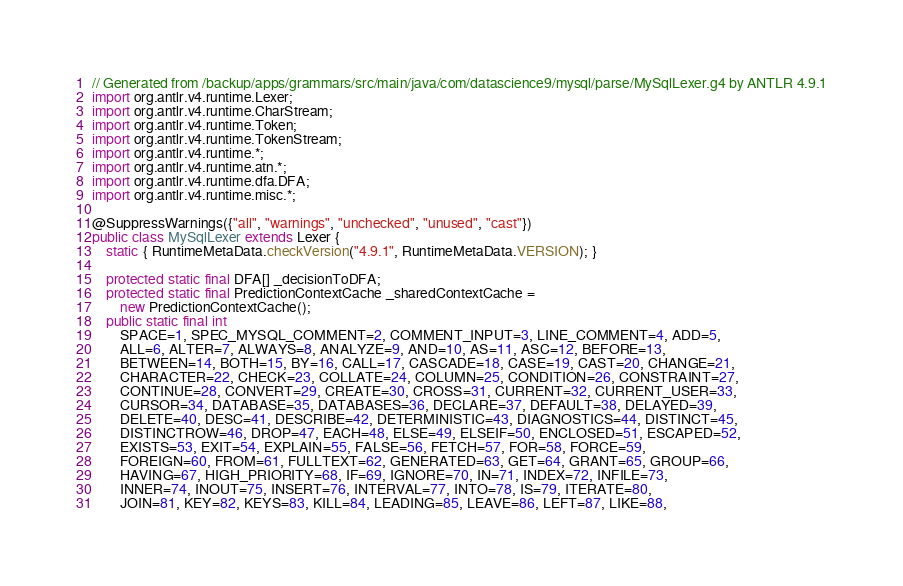Convert code to text. <code><loc_0><loc_0><loc_500><loc_500><_Java_>// Generated from /backup/apps/grammars/src/main/java/com/datascience9/mysql/parse/MySqlLexer.g4 by ANTLR 4.9.1
import org.antlr.v4.runtime.Lexer;
import org.antlr.v4.runtime.CharStream;
import org.antlr.v4.runtime.Token;
import org.antlr.v4.runtime.TokenStream;
import org.antlr.v4.runtime.*;
import org.antlr.v4.runtime.atn.*;
import org.antlr.v4.runtime.dfa.DFA;
import org.antlr.v4.runtime.misc.*;

@SuppressWarnings({"all", "warnings", "unchecked", "unused", "cast"})
public class MySqlLexer extends Lexer {
	static { RuntimeMetaData.checkVersion("4.9.1", RuntimeMetaData.VERSION); }

	protected static final DFA[] _decisionToDFA;
	protected static final PredictionContextCache _sharedContextCache =
		new PredictionContextCache();
	public static final int
		SPACE=1, SPEC_MYSQL_COMMENT=2, COMMENT_INPUT=3, LINE_COMMENT=4, ADD=5, 
		ALL=6, ALTER=7, ALWAYS=8, ANALYZE=9, AND=10, AS=11, ASC=12, BEFORE=13, 
		BETWEEN=14, BOTH=15, BY=16, CALL=17, CASCADE=18, CASE=19, CAST=20, CHANGE=21, 
		CHARACTER=22, CHECK=23, COLLATE=24, COLUMN=25, CONDITION=26, CONSTRAINT=27, 
		CONTINUE=28, CONVERT=29, CREATE=30, CROSS=31, CURRENT=32, CURRENT_USER=33, 
		CURSOR=34, DATABASE=35, DATABASES=36, DECLARE=37, DEFAULT=38, DELAYED=39, 
		DELETE=40, DESC=41, DESCRIBE=42, DETERMINISTIC=43, DIAGNOSTICS=44, DISTINCT=45, 
		DISTINCTROW=46, DROP=47, EACH=48, ELSE=49, ELSEIF=50, ENCLOSED=51, ESCAPED=52, 
		EXISTS=53, EXIT=54, EXPLAIN=55, FALSE=56, FETCH=57, FOR=58, FORCE=59, 
		FOREIGN=60, FROM=61, FULLTEXT=62, GENERATED=63, GET=64, GRANT=65, GROUP=66, 
		HAVING=67, HIGH_PRIORITY=68, IF=69, IGNORE=70, IN=71, INDEX=72, INFILE=73, 
		INNER=74, INOUT=75, INSERT=76, INTERVAL=77, INTO=78, IS=79, ITERATE=80, 
		JOIN=81, KEY=82, KEYS=83, KILL=84, LEADING=85, LEAVE=86, LEFT=87, LIKE=88, </code> 